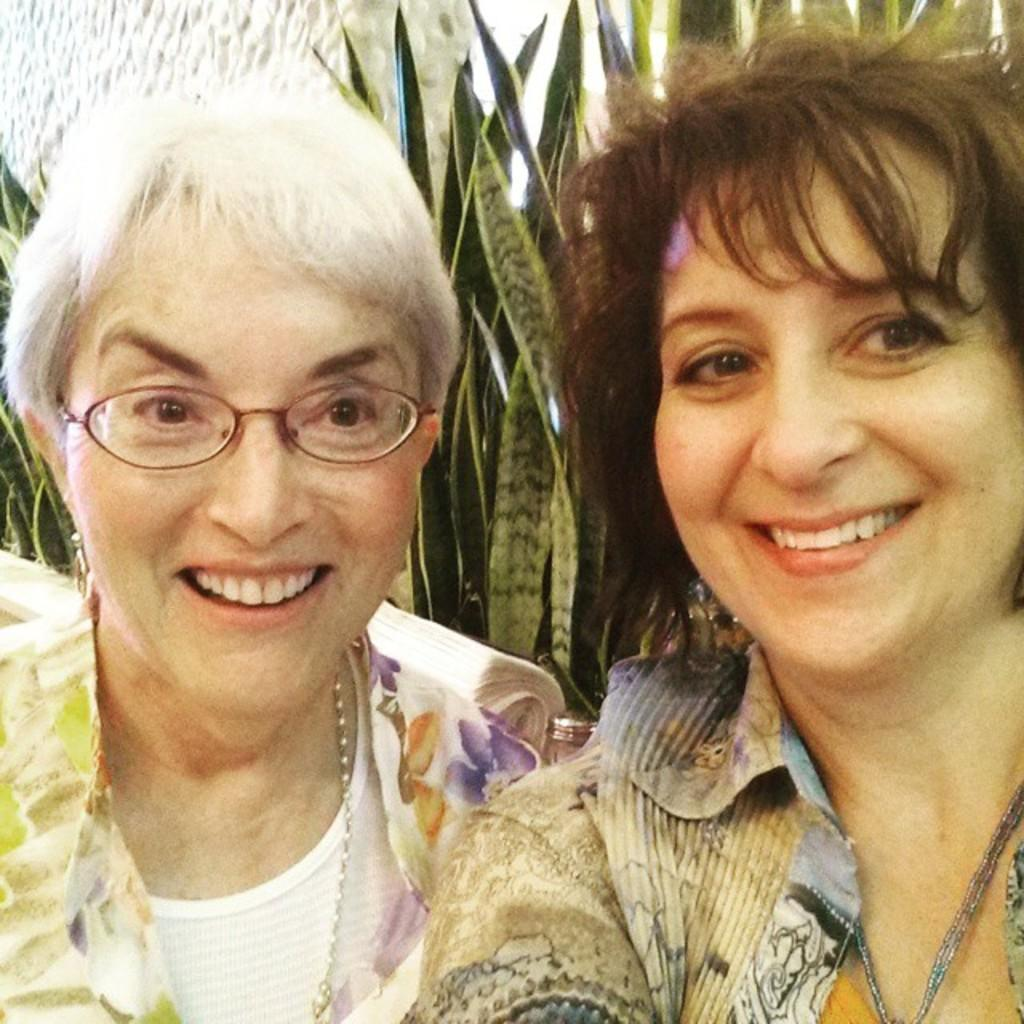How many people are in the image? There are two women in the image. What is the facial expression of the women? The women are smiling. What can be seen in the background of the image? There are leaves and objects in the background of the image. What type of copper object can be seen in the hands of one of the women? There is no copper object present in the image. What message of hope is conveyed by the women in the image? The image does not convey a specific message of hope; it simply shows two women smiling. 